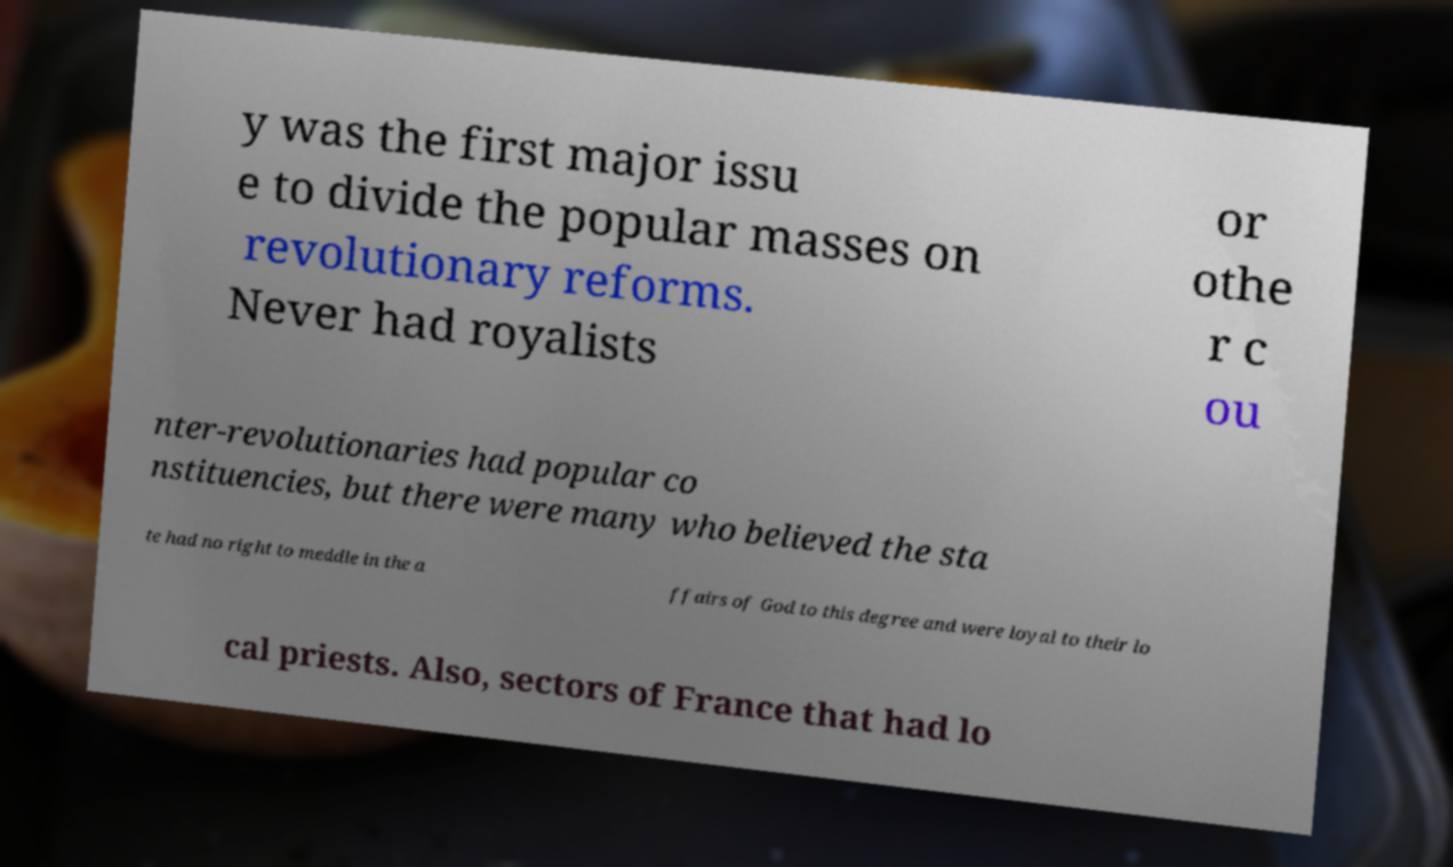Can you read and provide the text displayed in the image?This photo seems to have some interesting text. Can you extract and type it out for me? y was the first major issu e to divide the popular masses on revolutionary reforms. Never had royalists or othe r c ou nter-revolutionaries had popular co nstituencies, but there were many who believed the sta te had no right to meddle in the a ffairs of God to this degree and were loyal to their lo cal priests. Also, sectors of France that had lo 